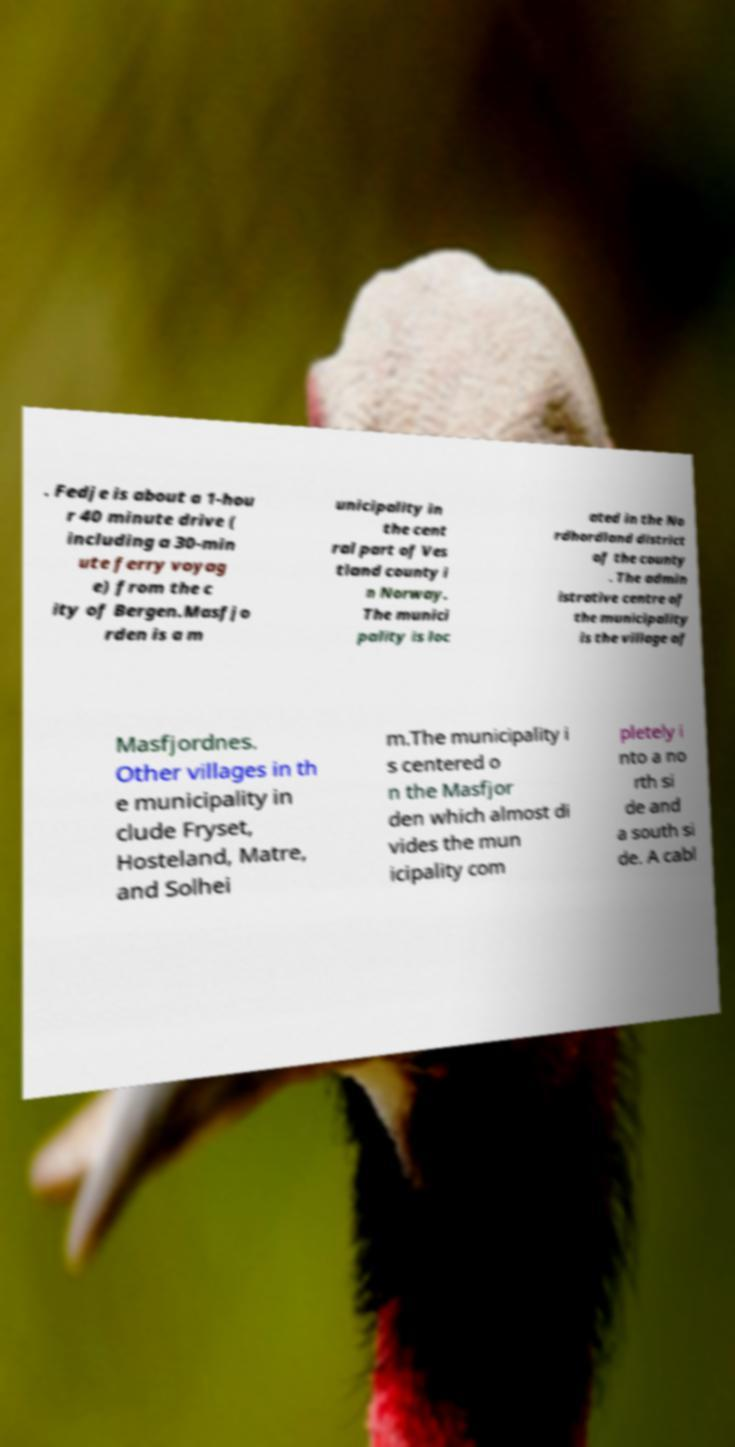What messages or text are displayed in this image? I need them in a readable, typed format. . Fedje is about a 1-hou r 40 minute drive ( including a 30-min ute ferry voyag e) from the c ity of Bergen.Masfjo rden is a m unicipality in the cent ral part of Ves tland county i n Norway. The munici pality is loc ated in the No rdhordland district of the county . The admin istrative centre of the municipality is the village of Masfjordnes. Other villages in th e municipality in clude Fryset, Hosteland, Matre, and Solhei m.The municipality i s centered o n the Masfjor den which almost di vides the mun icipality com pletely i nto a no rth si de and a south si de. A cabl 